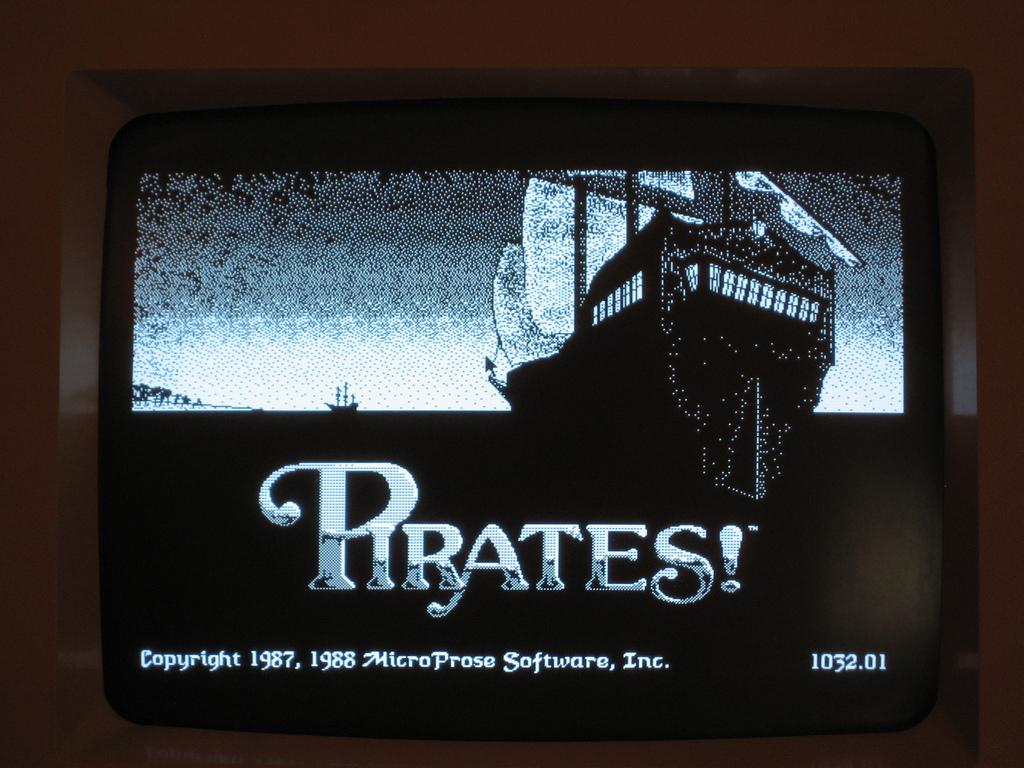What company made this game?
Your answer should be very brief. Microprose. What is the name of the game?
Provide a short and direct response. Pirates!. 